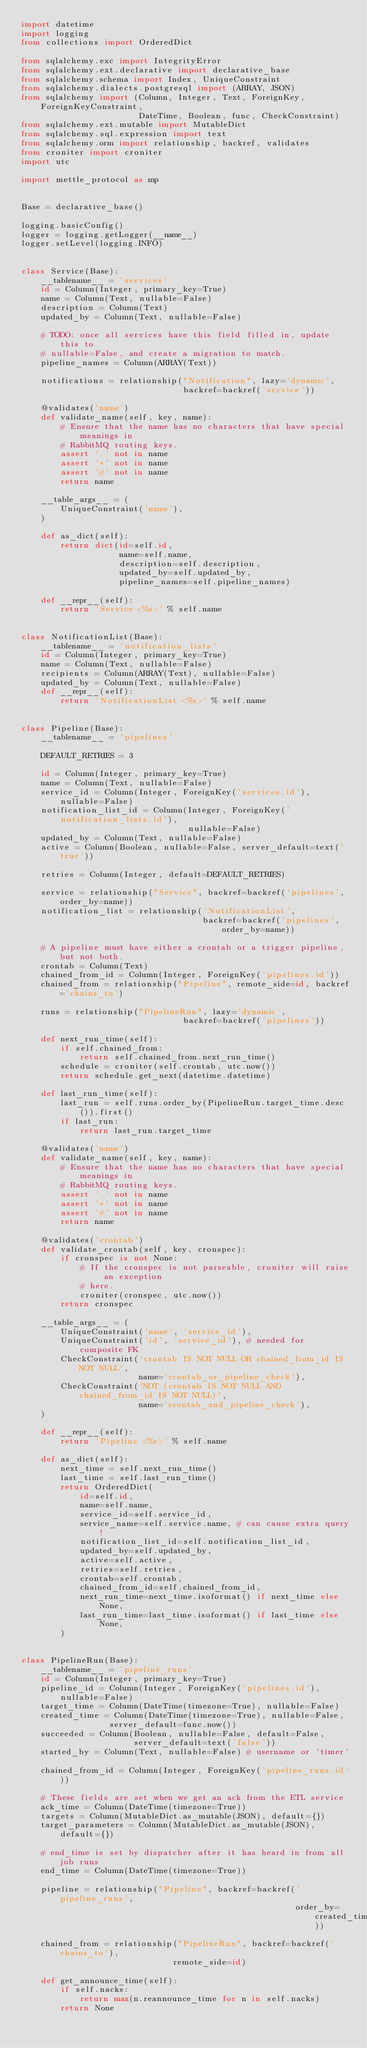<code> <loc_0><loc_0><loc_500><loc_500><_Python_>import datetime
import logging
from collections import OrderedDict

from sqlalchemy.exc import IntegrityError
from sqlalchemy.ext.declarative import declarative_base
from sqlalchemy.schema import Index, UniqueConstraint
from sqlalchemy.dialects.postgresql import (ARRAY, JSON)
from sqlalchemy import (Column, Integer, Text, ForeignKey, ForeignKeyConstraint,
                        DateTime, Boolean, func, CheckConstraint)
from sqlalchemy.ext.mutable import MutableDict
from sqlalchemy.sql.expression import text
from sqlalchemy.orm import relationship, backref, validates
from croniter import croniter
import utc

import mettle_protocol as mp


Base = declarative_base()

logging.basicConfig()
logger = logging.getLogger(__name__)
logger.setLevel(logging.INFO)


class Service(Base):
    __tablename__ = 'services'
    id = Column(Integer, primary_key=True)
    name = Column(Text, nullable=False)
    description = Column(Text)
    updated_by = Column(Text, nullable=False)

    # TODO: once all services have this field filled in, update this to
    # nullable=False, and create a migration to match.
    pipeline_names = Column(ARRAY(Text))

    notifications = relationship("Notification", lazy='dynamic',
                                 backref=backref('service'))

    @validates('name')
    def validate_name(self, key, name):
        # Ensure that the name has no characters that have special meanings in
        # RabbitMQ routing keys.
        assert '.' not in name
        assert '*' not in name
        assert '#' not in name
        return name

    __table_args__ = (
        UniqueConstraint('name'),
    )

    def as_dict(self):
        return dict(id=self.id,
                    name=self.name,
                    description=self.description,
                    updated_by=self.updated_by,
                    pipeline_names=self.pipeline_names)

    def __repr__(self):
        return 'Service <%s>' % self.name


class NotificationList(Base):
    __tablename__ = 'notification_lists'
    id = Column(Integer, primary_key=True)
    name = Column(Text, nullable=False)
    recipients = Column(ARRAY(Text), nullable=False)
    updated_by = Column(Text, nullable=False)
    def __repr__(self):
        return 'NotificationList <%s>' % self.name


class Pipeline(Base):
    __tablename__ = 'pipelines'

    DEFAULT_RETRIES = 3

    id = Column(Integer, primary_key=True)
    name = Column(Text, nullable=False)
    service_id = Column(Integer, ForeignKey('services.id'), nullable=False)
    notification_list_id = Column(Integer, ForeignKey('notification_lists.id'),
                                  nullable=False)
    updated_by = Column(Text, nullable=False)
    active = Column(Boolean, nullable=False, server_default=text('true'))

    retries = Column(Integer, default=DEFAULT_RETRIES)

    service = relationship("Service", backref=backref('pipelines', order_by=name))
    notification_list = relationship('NotificationList',
                                     backref=backref('pipelines', order_by=name))

    # A pipeline must have either a crontab or a trigger pipeline, but not both.
    crontab = Column(Text)
    chained_from_id = Column(Integer, ForeignKey('pipelines.id'))
    chained_from = relationship("Pipeline", remote_side=id, backref='chains_to')

    runs = relationship("PipelineRun", lazy='dynamic',
                                 backref=backref('pipelines'))

    def next_run_time(self):
        if self.chained_from:
            return self.chained_from.next_run_time()
        schedule = croniter(self.crontab, utc.now())
        return schedule.get_next(datetime.datetime)

    def last_run_time(self):
        last_run = self.runs.order_by(PipelineRun.target_time.desc()).first()
        if last_run:
            return last_run.target_time

    @validates('name')
    def validate_name(self, key, name):
        # Ensure that the name has no characters that have special meanings in
        # RabbitMQ routing keys.
        assert '.' not in name
        assert '*' not in name
        assert '#' not in name
        return name

    @validates('crontab')
    def validate_crontab(self, key, cronspec):
        if cronspec is not None:
            # If the cronspec is not parseable, croniter will raise an exception
            # here.
            croniter(cronspec, utc.now())
        return cronspec

    __table_args__ = (
        UniqueConstraint('name', 'service_id'),
        UniqueConstraint('id', 'service_id'), # needed for composite FK
        CheckConstraint('crontab IS NOT NULL OR chained_from_id IS NOT NULL',
                        name='crontab_or_pipeline_check'),
        CheckConstraint('NOT (crontab IS NOT NULL AND chained_from_id IS NOT NULL)',
                        name='crontab_and_pipeline_check'),
    )

    def __repr__(self):
        return 'Pipeline <%s>' % self.name

    def as_dict(self):
        next_time = self.next_run_time()
        last_time = self.last_run_time()
        return OrderedDict(
            id=self.id,
            name=self.name,
            service_id=self.service_id,
            service_name=self.service.name, # can cause extra query!
            notification_list_id=self.notification_list_id,
            updated_by=self.updated_by,
            active=self.active,
            retries=self.retries,
            crontab=self.crontab,
            chained_from_id=self.chained_from_id,
            next_run_time=next_time.isoformat() if next_time else None,
            last_run_time=last_time.isoformat() if last_time else None,
        )


class PipelineRun(Base):
    __tablename__ = 'pipeline_runs'
    id = Column(Integer, primary_key=True)
    pipeline_id = Column(Integer, ForeignKey('pipelines.id'), nullable=False)
    target_time = Column(DateTime(timezone=True), nullable=False)
    created_time = Column(DateTime(timezone=True), nullable=False,
                  server_default=func.now())
    succeeded = Column(Boolean, nullable=False, default=False,
                       server_default=text('false'))
    started_by = Column(Text, nullable=False) # username or 'timer'

    chained_from_id = Column(Integer, ForeignKey('pipeline_runs.id'))

    # These fields are set when we get an ack from the ETL service
    ack_time = Column(DateTime(timezone=True))
    targets = Column(MutableDict.as_mutable(JSON), default={})
    target_parameters = Column(MutableDict.as_mutable(JSON), default={})

    # end_time is set by dispatcher after it has heard in from all job runs
    end_time = Column(DateTime(timezone=True))

    pipeline = relationship("Pipeline", backref=backref('pipeline_runs',
                                                        order_by=created_time))

    chained_from = relationship("PipelineRun", backref=backref('chains_to'),
                               remote_side=id)

    def get_announce_time(self):
        if self.nacks:
            return max(n.reannounce_time for n in self.nacks)
        return None
</code> 